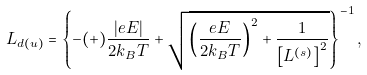<formula> <loc_0><loc_0><loc_500><loc_500>L _ { d ( u ) } = \left \{ - ( + ) \frac { \left | e E \right | } { 2 k _ { B } T } + \sqrt { \left ( \frac { e E } { 2 k _ { B } T } \right ) ^ { 2 } + \frac { 1 } { \left [ L ^ { ( s ) } \right ] ^ { 2 } } } \right \} ^ { - 1 } ,</formula> 